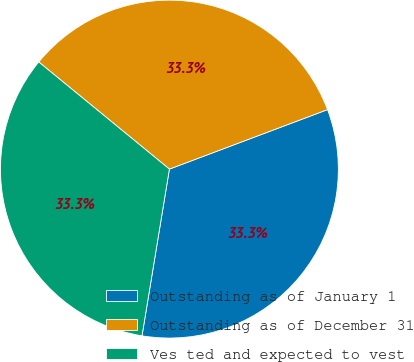<chart> <loc_0><loc_0><loc_500><loc_500><pie_chart><fcel>Outstanding as of January 1<fcel>Outstanding as of December 31<fcel>Ves ted and expected to vest<nl><fcel>33.32%<fcel>33.34%<fcel>33.34%<nl></chart> 